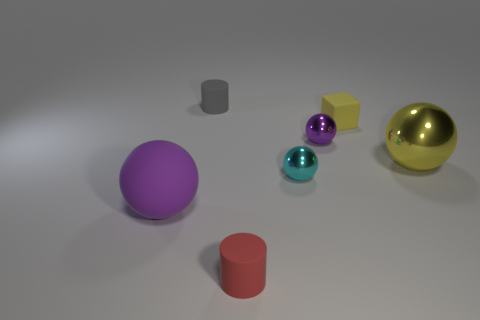Subtract 1 spheres. How many spheres are left? 3 Subtract all red balls. Subtract all yellow blocks. How many balls are left? 4 Add 3 small cyan things. How many objects exist? 10 Subtract all spheres. How many objects are left? 3 Subtract 0 blue balls. How many objects are left? 7 Subtract all tiny objects. Subtract all small red rubber cylinders. How many objects are left? 1 Add 5 large rubber objects. How many large rubber objects are left? 6 Add 7 tiny blue metallic spheres. How many tiny blue metallic spheres exist? 7 